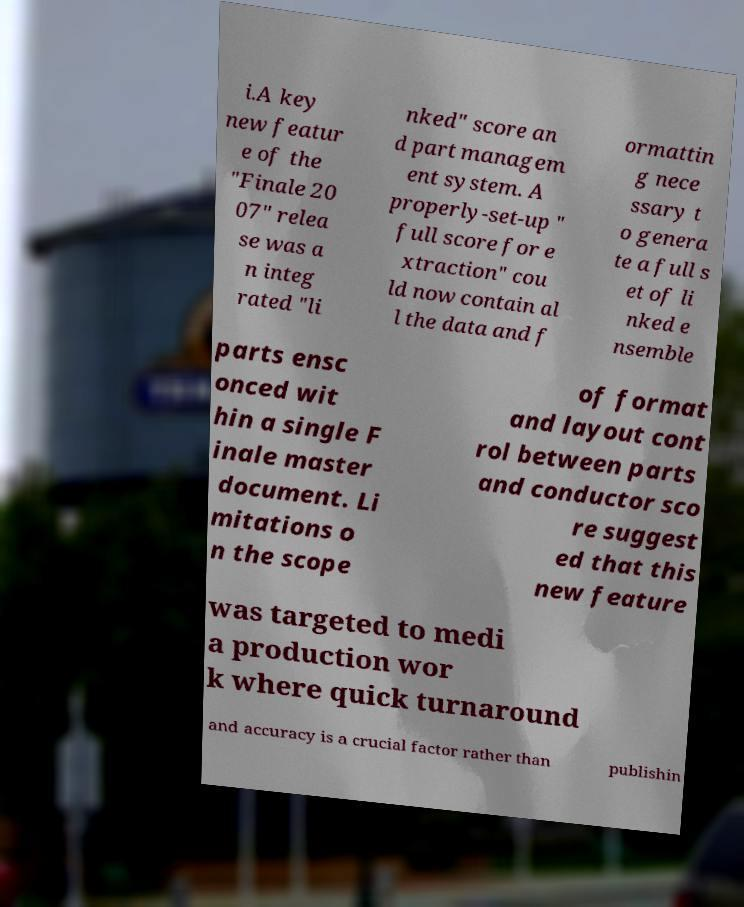Could you extract and type out the text from this image? i.A key new featur e of the "Finale 20 07" relea se was a n integ rated "li nked" score an d part managem ent system. A properly-set-up " full score for e xtraction" cou ld now contain al l the data and f ormattin g nece ssary t o genera te a full s et of li nked e nsemble parts ensc onced wit hin a single F inale master document. Li mitations o n the scope of format and layout cont rol between parts and conductor sco re suggest ed that this new feature was targeted to medi a production wor k where quick turnaround and accuracy is a crucial factor rather than publishin 